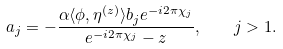<formula> <loc_0><loc_0><loc_500><loc_500>a _ { j } = - \frac { \alpha \langle \phi , \eta ^ { ( z ) } \rangle b _ { j } e ^ { - i 2 \pi \chi _ { j } } } { e ^ { - i 2 \pi \chi _ { j } } - z } , \quad j > 1 .</formula> 